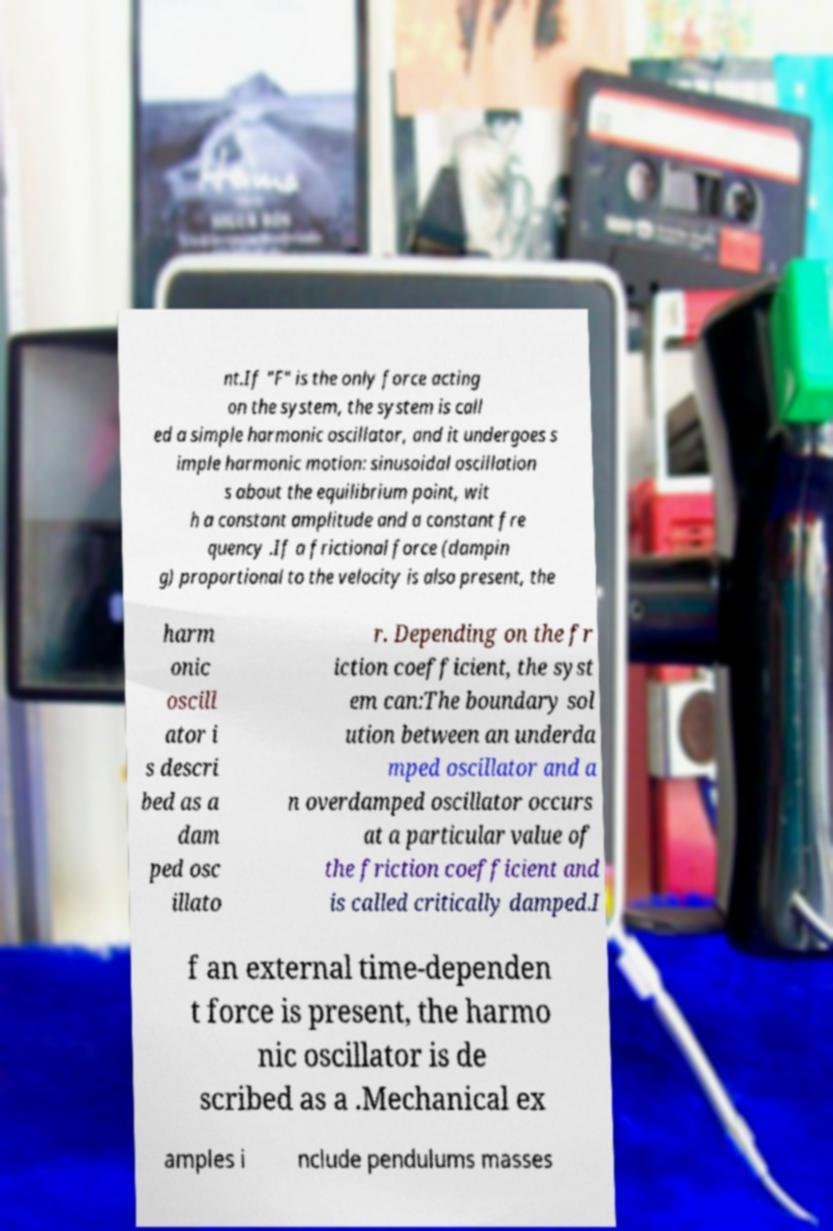I need the written content from this picture converted into text. Can you do that? nt.If "F" is the only force acting on the system, the system is call ed a simple harmonic oscillator, and it undergoes s imple harmonic motion: sinusoidal oscillation s about the equilibrium point, wit h a constant amplitude and a constant fre quency .If a frictional force (dampin g) proportional to the velocity is also present, the harm onic oscill ator i s descri bed as a dam ped osc illato r. Depending on the fr iction coefficient, the syst em can:The boundary sol ution between an underda mped oscillator and a n overdamped oscillator occurs at a particular value of the friction coefficient and is called critically damped.I f an external time-dependen t force is present, the harmo nic oscillator is de scribed as a .Mechanical ex amples i nclude pendulums masses 